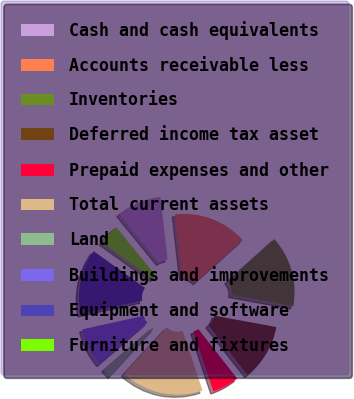Convert chart. <chart><loc_0><loc_0><loc_500><loc_500><pie_chart><fcel>Cash and cash equivalents<fcel>Accounts receivable less<fcel>Inventories<fcel>Deferred income tax asset<fcel>Prepaid expenses and other<fcel>Total current assets<fcel>Land<fcel>Buildings and improvements<fcel>Equipment and software<fcel>Furniture and fixtures<nl><fcel>9.09%<fcel>15.15%<fcel>14.54%<fcel>11.51%<fcel>5.46%<fcel>16.97%<fcel>1.82%<fcel>7.88%<fcel>13.33%<fcel>4.24%<nl></chart> 